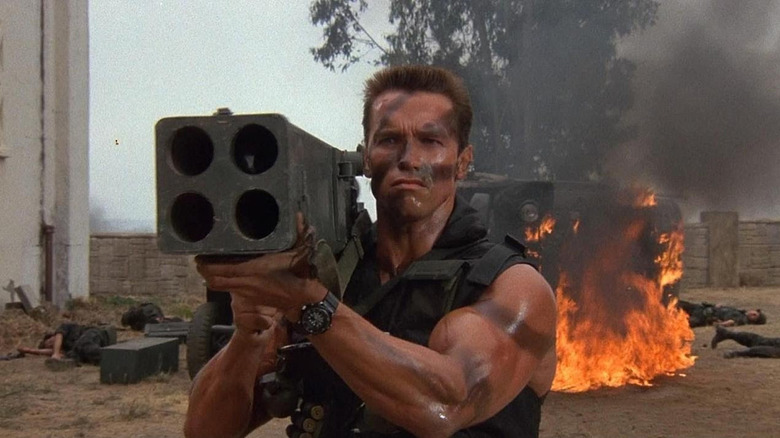What might be going through the character's mind in this scene? The character likely experiences a mix of determination and urgency. His focused expression and poised stance with the weapon suggest that he is ready to confront significant threats, possibly to protect others or complete a critical mission. 